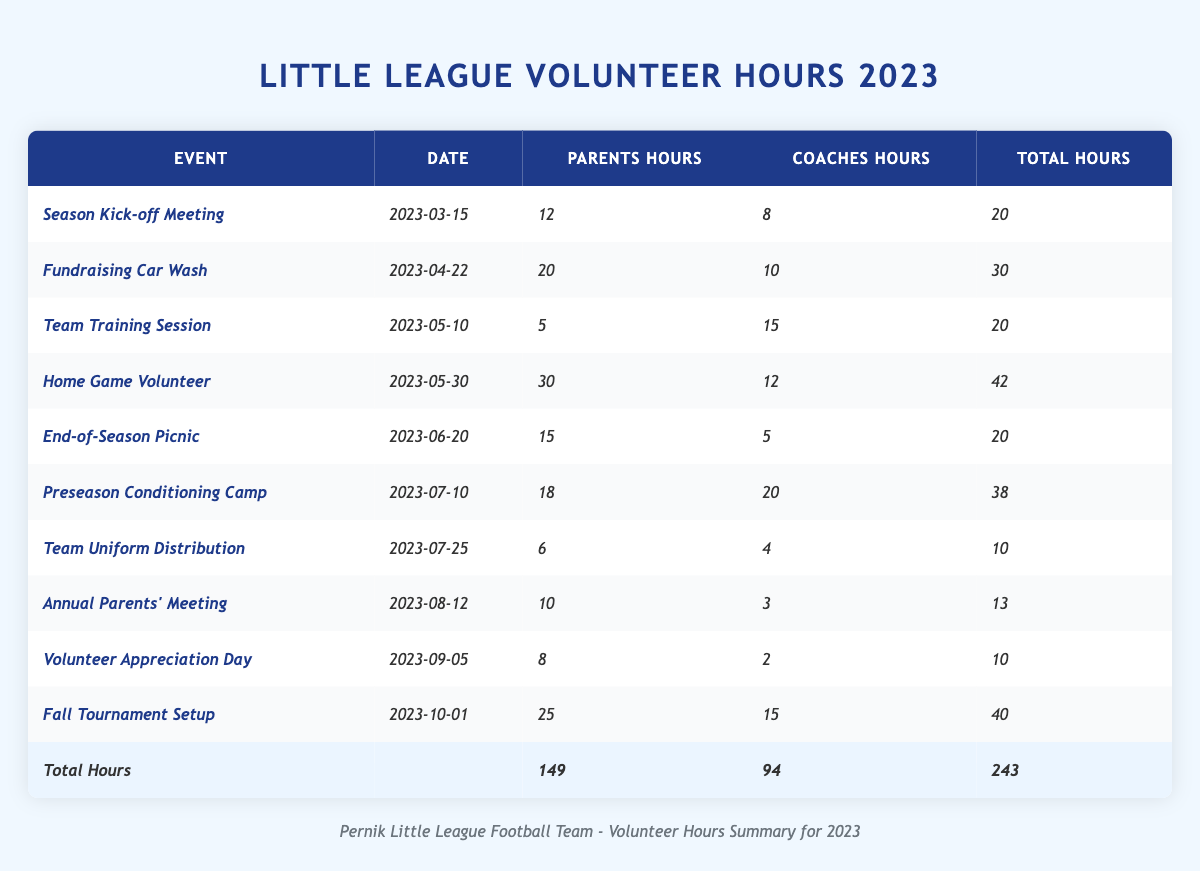What event had the highest number of volunteer hours contributed by parents? To find the event with the highest number of volunteer hours from parents, we look at the 'Parents Hours' column and identify the maximum value. The 'Home Game Volunteer' event has 30 parent hours, which is the highest compared to other events.
Answer: Home Game Volunteer How many total volunteer hours were contributed by coaches during all events? We need to sum the values in the 'Coaches Hours' column. The total is calculated as follows: 8 + 10 + 15 + 12 + 5 + 20 + 4 + 3 + 2 + 15 = 94.
Answer: 94 What was the average number of volunteer hours contributed by parents across all events? To find the average, first, we sum the 'Parents Hours' values: 12 + 20 + 5 + 30 + 15 + 18 + 6 + 10 + 8 + 25 = 149. There are 10 events, so the average is 149 / 10 = 14.9.
Answer: 14.9 Which event contributed the least amount of volunteer hours in total? Total hours for each event are found by adding both 'Parents Hours' and 'Coaches Hours' for each event. The event with the lowest total is 'Team Uniform Distribution', with 10 hours (6 + 4).
Answer: Team Uniform Distribution Did parents contribute more volunteer hours during the 'Fundraising Car Wash' than during the 'Volunteer Appreciation Day'? Comparing the 'Parents Hours' for both events, 'Fundraising Car Wash' has 20 hours and 'Volunteer Appreciation Day' has 8 hours. Since 20 is greater than 8, parents contributed more during the 'Fundraising Car Wash'.
Answer: Yes What is the difference between the total volunteer hours from parents and coaches? The total volunteer hours for parents is 149, and for coaches, it is 94. To find the difference, we calculate 149 - 94 = 55.
Answer: 55 In what month was the 'End-of-Season Picnic' held, and how many total hours were contributed? The 'End-of-Season Picnic' was held on June 20, 2023. The total hours contributed for this event is calculated as 15 (parents) + 5 (coaches) = 20 total hours.
Answer: June, 20 What percentage of the total volunteer hours was contributed by parents? The total volunteer hours are 243 (from the last row of the table). To find the percentage contributed by parents, we use: (149 / 243) * 100 ≈ 61.3%.
Answer: 61.3% How many events had more than 15 hours contributed by coaches? We will count the events with 'Coaches Hours' greater than 15. The events are 'Team Training Session', 'Preseason Conditioning Camp', and 'Fall Tournament Setup'. This gives a total of 3 events.
Answer: 3 What was the total number of volunteer hours from the 'Preseason Conditioning Camp'? We can find the total hours contributed for this event by adding the 'Parents Hours' (18) and 'Coaches Hours' (20): 18 + 20 = 38.
Answer: 38 